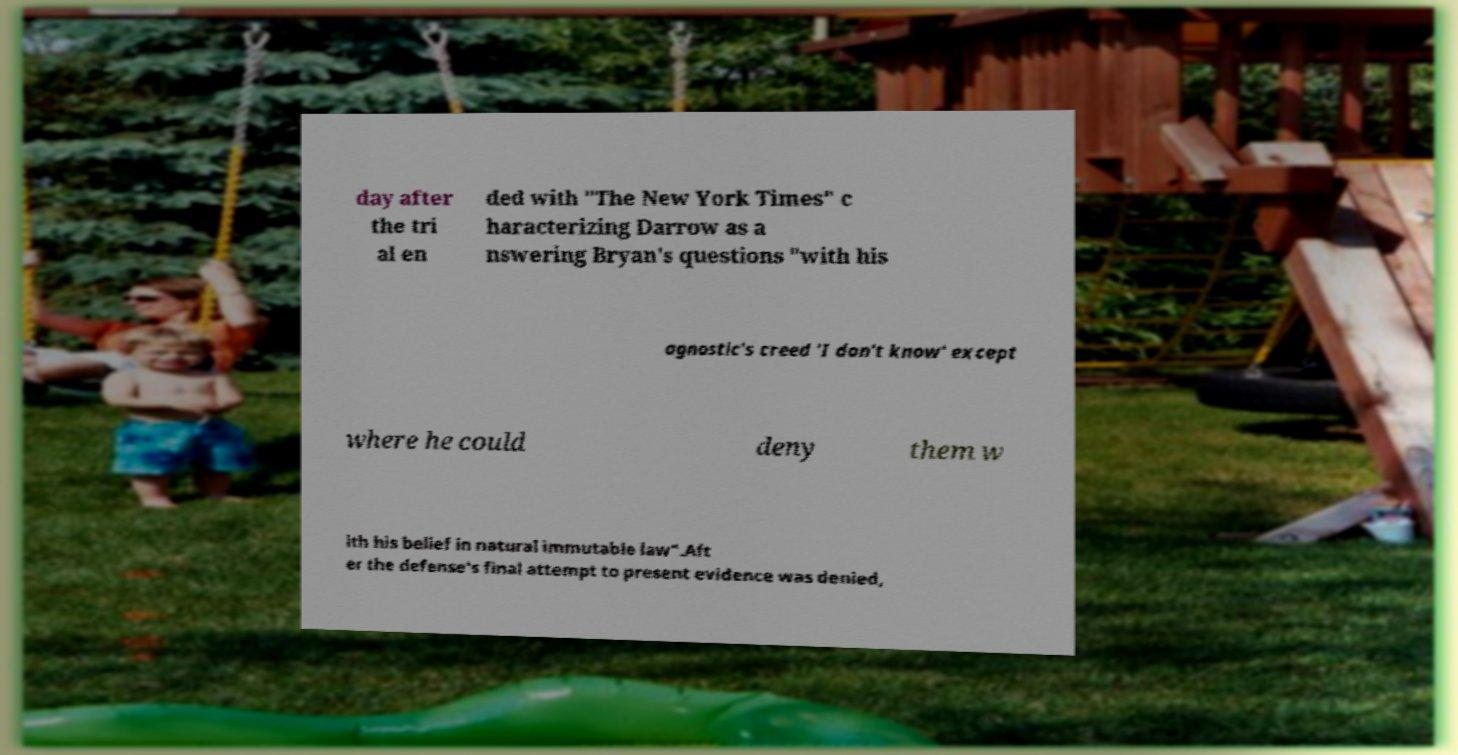I need the written content from this picture converted into text. Can you do that? day after the tri al en ded with "The New York Times" c haracterizing Darrow as a nswering Bryan's questions "with his agnostic's creed 'I don't know' except where he could deny them w ith his belief in natural immutable law".Aft er the defense's final attempt to present evidence was denied, 